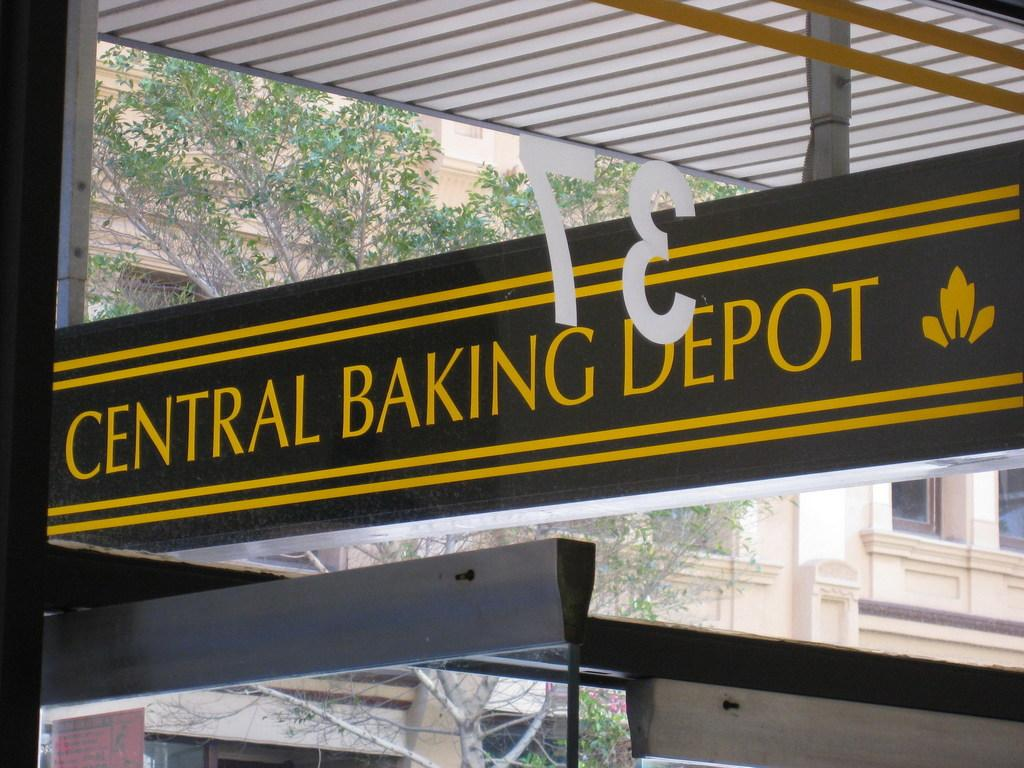What type of object is made of glass in the image? There is a glass object in the image. What is on the glass object? A sticker is present on the glass. What structure can be seen at the top of the image? There is a shed at the top of the image. What can be seen in the background of the image? Trees and buildings are visible in the background of the image. Where is the library located in the image? There is no library present in the image. Are there any masks visible on the glass object? There are no masks present on the glass object in the image. 